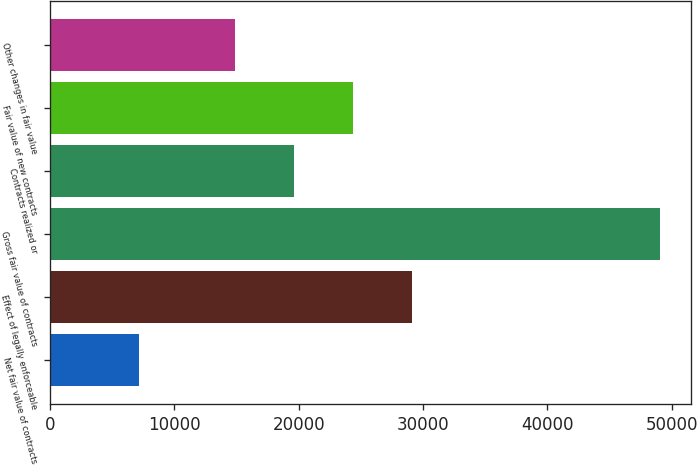Convert chart. <chart><loc_0><loc_0><loc_500><loc_500><bar_chart><fcel>Net fair value of contracts<fcel>Effect of legally enforceable<fcel>Gross fair value of contracts<fcel>Contracts realized or<fcel>Fair value of new contracts<fcel>Other changes in fair value<nl><fcel>7184<fcel>29123.8<fcel>49103<fcel>19650.6<fcel>24387.2<fcel>14914<nl></chart> 